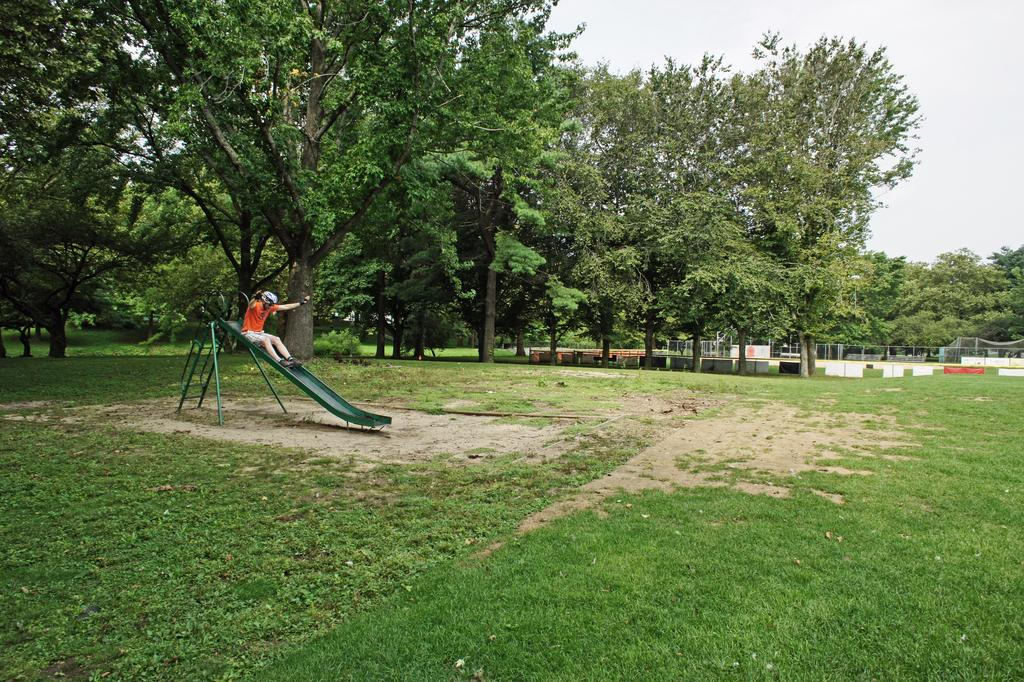What type of vegetation is present in the image? There is grass in the image. What playground equipment can be seen in the image? There is a slide in the image. Is there anyone using the slide in the image? Yes, a person is on the slide. What other natural elements are visible in the image? There are trees in the image. What can be seen in the background of the image? The sky is visible in the background of the image. Can you tell me how many cats are sitting on the slide in the image? There are no cats present in the image; it features a person on the slide. What type of utensil is being used by the person on the slide in the image? There is no utensil, such as a fork, present in the image. 